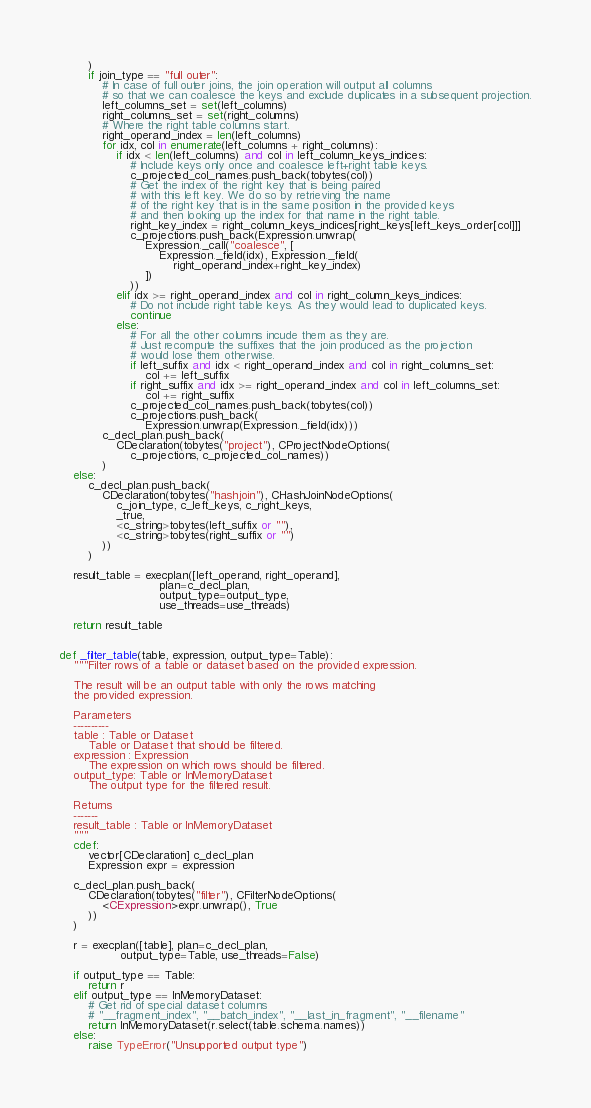<code> <loc_0><loc_0><loc_500><loc_500><_Cython_>        )
        if join_type == "full outer":
            # In case of full outer joins, the join operation will output all columns
            # so that we can coalesce the keys and exclude duplicates in a subsequent projection.
            left_columns_set = set(left_columns)
            right_columns_set = set(right_columns)
            # Where the right table columns start.
            right_operand_index = len(left_columns)
            for idx, col in enumerate(left_columns + right_columns):
                if idx < len(left_columns) and col in left_column_keys_indices:
                    # Include keys only once and coalesce left+right table keys.
                    c_projected_col_names.push_back(tobytes(col))
                    # Get the index of the right key that is being paired
                    # with this left key. We do so by retrieving the name
                    # of the right key that is in the same position in the provided keys
                    # and then looking up the index for that name in the right table.
                    right_key_index = right_column_keys_indices[right_keys[left_keys_order[col]]]
                    c_projections.push_back(Expression.unwrap(
                        Expression._call("coalesce", [
                            Expression._field(idx), Expression._field(
                                right_operand_index+right_key_index)
                        ])
                    ))
                elif idx >= right_operand_index and col in right_column_keys_indices:
                    # Do not include right table keys. As they would lead to duplicated keys.
                    continue
                else:
                    # For all the other columns incude them as they are.
                    # Just recompute the suffixes that the join produced as the projection
                    # would lose them otherwise.
                    if left_suffix and idx < right_operand_index and col in right_columns_set:
                        col += left_suffix
                    if right_suffix and idx >= right_operand_index and col in left_columns_set:
                        col += right_suffix
                    c_projected_col_names.push_back(tobytes(col))
                    c_projections.push_back(
                        Expression.unwrap(Expression._field(idx)))
            c_decl_plan.push_back(
                CDeclaration(tobytes("project"), CProjectNodeOptions(
                    c_projections, c_projected_col_names))
            )
    else:
        c_decl_plan.push_back(
            CDeclaration(tobytes("hashjoin"), CHashJoinNodeOptions(
                c_join_type, c_left_keys, c_right_keys,
                _true,
                <c_string>tobytes(left_suffix or ""),
                <c_string>tobytes(right_suffix or "")
            ))
        )

    result_table = execplan([left_operand, right_operand],
                            plan=c_decl_plan,
                            output_type=output_type,
                            use_threads=use_threads)

    return result_table


def _filter_table(table, expression, output_type=Table):
    """Filter rows of a table or dataset based on the provided expression.

    The result will be an output table with only the rows matching
    the provided expression.

    Parameters
    ----------
    table : Table or Dataset
        Table or Dataset that should be filtered.
    expression : Expression
        The expression on which rows should be filtered.
    output_type: Table or InMemoryDataset
        The output type for the filtered result.

    Returns
    -------
    result_table : Table or InMemoryDataset
    """
    cdef:
        vector[CDeclaration] c_decl_plan
        Expression expr = expression

    c_decl_plan.push_back(
        CDeclaration(tobytes("filter"), CFilterNodeOptions(
            <CExpression>expr.unwrap(), True
        ))
    )

    r = execplan([table], plan=c_decl_plan,
                 output_type=Table, use_threads=False)

    if output_type == Table:
        return r
    elif output_type == InMemoryDataset:
        # Get rid of special dataset columns
        # "__fragment_index", "__batch_index", "__last_in_fragment", "__filename"
        return InMemoryDataset(r.select(table.schema.names))
    else:
        raise TypeError("Unsupported output type")
</code> 